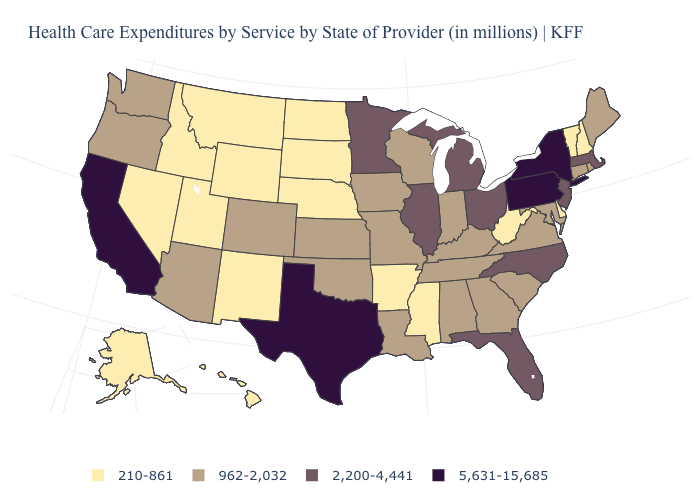Which states hav the highest value in the MidWest?
Quick response, please. Illinois, Michigan, Minnesota, Ohio. Which states hav the highest value in the West?
Give a very brief answer. California. Which states hav the highest value in the Northeast?
Quick response, please. New York, Pennsylvania. What is the value of Oregon?
Give a very brief answer. 962-2,032. Does Delaware have the lowest value in the South?
Be succinct. Yes. How many symbols are there in the legend?
Be succinct. 4. What is the highest value in states that border Rhode Island?
Be succinct. 2,200-4,441. What is the lowest value in states that border Montana?
Quick response, please. 210-861. What is the lowest value in the MidWest?
Concise answer only. 210-861. Does Kentucky have a higher value than Maine?
Short answer required. No. Among the states that border Oregon , does Nevada have the lowest value?
Quick response, please. Yes. What is the value of Idaho?
Concise answer only. 210-861. How many symbols are there in the legend?
Short answer required. 4. What is the lowest value in states that border South Dakota?
Quick response, please. 210-861. 